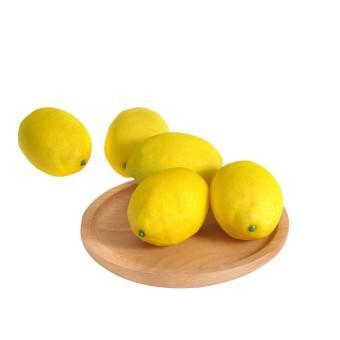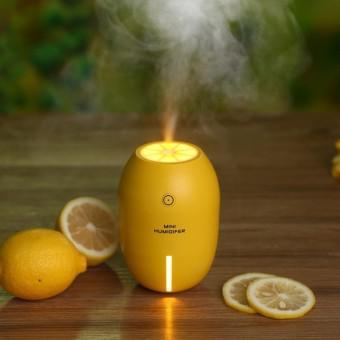The first image is the image on the left, the second image is the image on the right. For the images displayed, is the sentence "The left image depicts a cut lemon half in front of a whole lemon and green leaves and include an upright product container, and the right image contains a mass of whole lemons only." factually correct? Answer yes or no. No. The first image is the image on the left, the second image is the image on the right. For the images shown, is this caption "There is a real sliced lemon in the left image." true? Answer yes or no. No. 